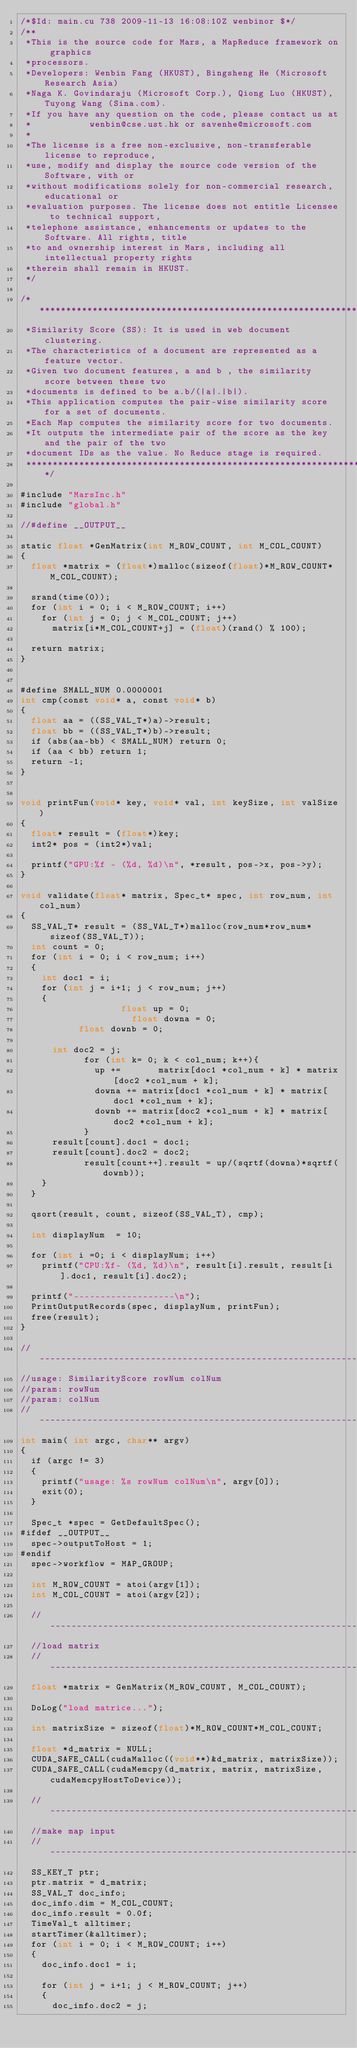<code> <loc_0><loc_0><loc_500><loc_500><_Cuda_>/*$Id: main.cu 738 2009-11-13 16:08:10Z wenbinor $*/
/**
 *This is the source code for Mars, a MapReduce framework on graphics
 *processors.
 *Developers: Wenbin Fang (HKUST), Bingsheng He (Microsoft Research Asia)
 *Naga K. Govindaraju (Microsoft Corp.), Qiong Luo (HKUST), Tuyong Wang (Sina.com).
 *If you have any question on the code, please contact us at 
 *           wenbin@cse.ust.hk or savenhe@microsoft.com
 *
 *The license is a free non-exclusive, non-transferable license to reproduce, 
 *use, modify and display the source code version of the Software, with or 
 *without modifications solely for non-commercial research, educational or 
 *evaluation purposes. The license does not entitle Licensee to technical support, 
 *telephone assistance, enhancements or updates to the Software. All rights, title 
 *to and ownership interest in Mars, including all intellectual property rights 
 *therein shall remain in HKUST.
 */

/*********************************************************************************
 *Similarity Score (SS): It is used in web document clustering. 
 *The characteristics of a document are represented as a feature vector. 
 *Given two document features, a and b , the similarity score between these two
 *documents is defined to be a.b/(|a|.|b|).
 *This application computes the pair-wise similarity score for a set of documents. 
 *Each Map computes the similarity score for two documents. 
 *It outputs the intermediate pair of the score as the key and the pair of the two 
 *document IDs as the value. No Reduce stage is required.
 *********************************************************************************/

#include "MarsInc.h"
#include "global.h"

//#define __OUTPUT__

static float *GenMatrix(int M_ROW_COUNT, int M_COL_COUNT)
{
	float *matrix = (float*)malloc(sizeof(float)*M_ROW_COUNT*M_COL_COUNT);

	srand(time(0));
	for (int i = 0; i < M_ROW_COUNT; i++)
		for (int j = 0; j < M_COL_COUNT; j++)
			matrix[i*M_COL_COUNT+j] = (float)(rand() % 100);

	return matrix;
}


#define SMALL_NUM	0.0000001
int cmp(const void* a, const void* b)
{
	float aa = ((SS_VAL_T*)a)->result;
	float bb = ((SS_VAL_T*)b)->result;
	if (abs(aa-bb) < SMALL_NUM) return 0;
	if (aa < bb) return 1;
	return -1;
}


void printFun(void* key, void* val, int keySize, int valSize)
{
	float* result = (float*)key;
	int2* pos = (int2*)val;

	printf("GPU:%f - (%d, %d)\n", *result, pos->x, pos->y);
}

void validate(float* matrix, Spec_t* spec, int row_num, int col_num)
{
	SS_VAL_T* result = (SS_VAL_T*)malloc(row_num*row_num*sizeof(SS_VAL_T));
	int count = 0;
	for (int i = 0; i < row_num; i++)
	{
		int doc1 = i;
		for (int j = i+1; j < row_num; j++)
		{
             	     float up = 0;
      	             float downa = 0;
   		     float downb = 0;

			int doc2 = j;
        		for (int k= 0; k < col_num; k++){
         			up +=       matrix[doc1 *col_num + k] * matrix[doc2 *col_num + k];
         			downa += matrix[doc1 *col_num + k] * matrix[doc1 *col_num + k];
         			downb += matrix[doc2 *col_num + k] * matrix[doc2 *col_num + k];
        		}
			result[count].doc1 = doc1;
			result[count].doc2 = doc2;
       			result[count++].result = up/(sqrtf(downa)*sqrtf(downb));
		}
	}

	qsort(result, count, sizeof(SS_VAL_T), cmp);

	int displayNum  = 10;
	
	for (int i =0; i < displayNum; i++)
		printf("CPU:%f- (%d, %d)\n", result[i].result, result[i].doc1, result[i].doc2);

	printf("-------------------\n");
	PrintOutputRecords(spec, displayNum, printFun);
	free(result);
}

//--------------------------------------------------------------------
//usage: SimilarityScore rowNum colNum 
//param: rowNum
//param: colNum
//--------------------------------------------------------------------
int main( int argc, char** argv) 
{
	if (argc != 3)
	{
		printf("usage: %s rowNum colNum\n", argv[0]);
		exit(0);
	}

	Spec_t *spec = GetDefaultSpec();
#ifdef __OUTPUT__
	spec->outputToHost = 1;
#endif
	spec->workflow = MAP_GROUP;

	int M_ROW_COUNT = atoi(argv[1]);
	int M_COL_COUNT = atoi(argv[2]);
	
	//----------------------------------------------------------
	//load matrix
	//----------------------------------------------------------
	float *matrix = GenMatrix(M_ROW_COUNT, M_COL_COUNT);

	DoLog("load matrice...");

	int matrixSize = sizeof(float)*M_ROW_COUNT*M_COL_COUNT;

	float *d_matrix = NULL;
	CUDA_SAFE_CALL(cudaMalloc((void**)&d_matrix, matrixSize));
	CUDA_SAFE_CALL(cudaMemcpy(d_matrix, matrix, matrixSize, cudaMemcpyHostToDevice));

	//-----------------------------------------------------------
	//make map input
	//-----------------------------------------------------------
	SS_KEY_T ptr;
	ptr.matrix = d_matrix;
	SS_VAL_T doc_info;
	doc_info.dim = M_COL_COUNT;
	doc_info.result = 0.0f;
	TimeVal_t alltimer;
	startTimer(&alltimer);
	for (int i = 0; i < M_ROW_COUNT; i++)
	{
		doc_info.doc1 = i;

		for (int j = i+1; j < M_ROW_COUNT; j++)
		{
			doc_info.doc2 = j;</code> 